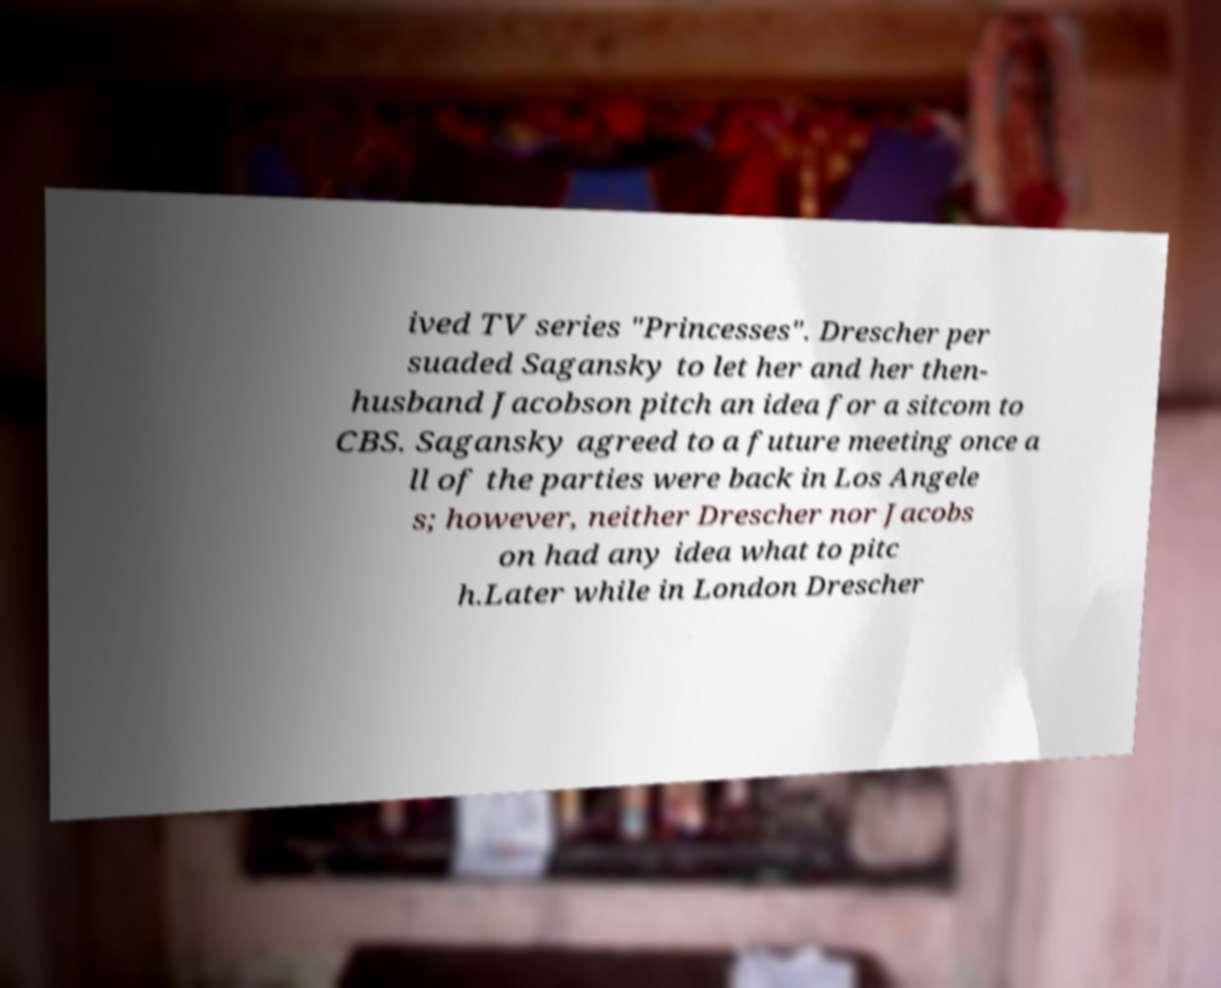Please identify and transcribe the text found in this image. ived TV series "Princesses". Drescher per suaded Sagansky to let her and her then- husband Jacobson pitch an idea for a sitcom to CBS. Sagansky agreed to a future meeting once a ll of the parties were back in Los Angele s; however, neither Drescher nor Jacobs on had any idea what to pitc h.Later while in London Drescher 